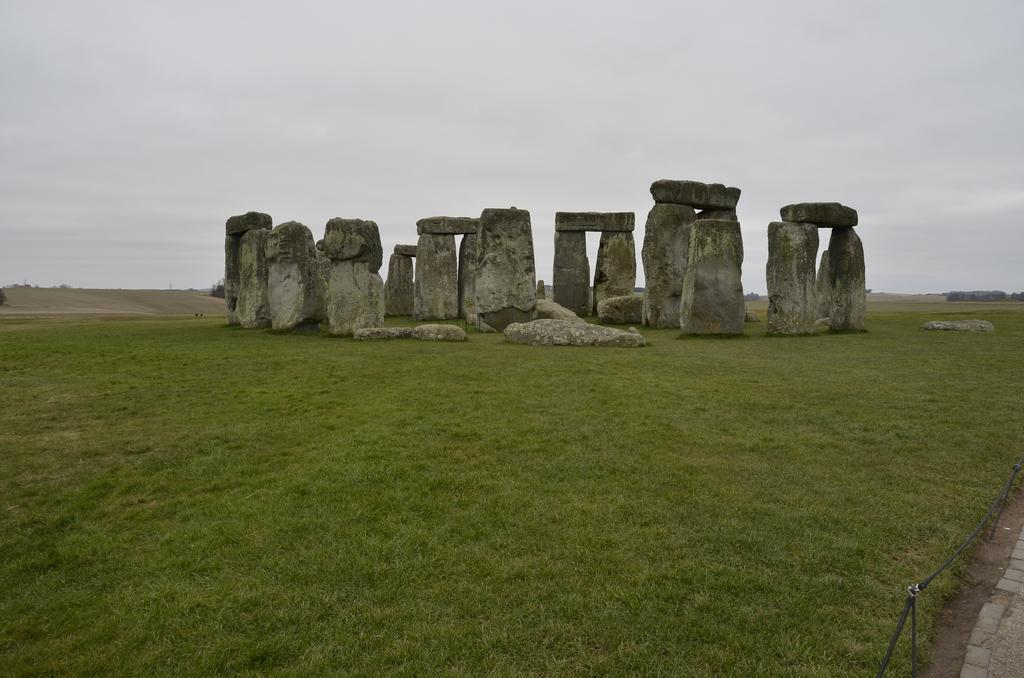Can you describe this image briefly? In this image we can see this ground is full of grass and in the middle there are rocks one over the other background is the sky. 